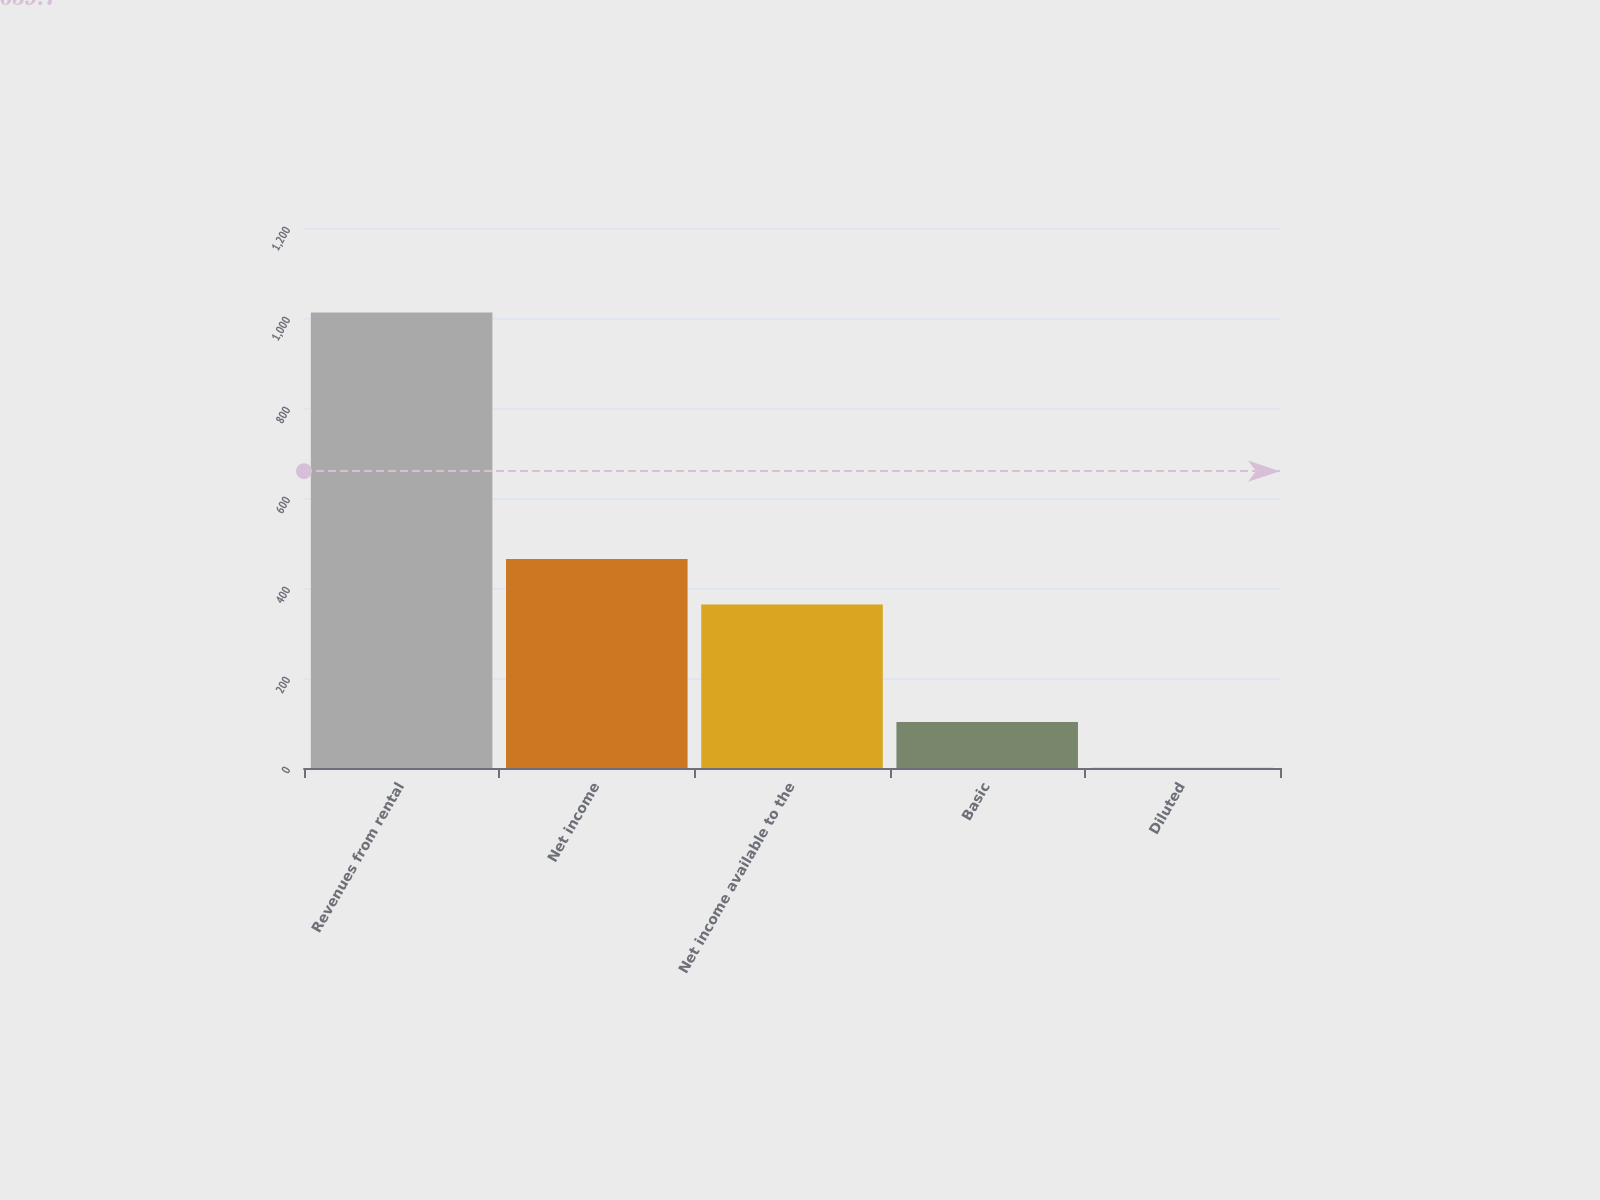<chart> <loc_0><loc_0><loc_500><loc_500><bar_chart><fcel>Revenues from rental<fcel>Net income<fcel>Net income available to the<fcel>Basic<fcel>Diluted<nl><fcel>1012.5<fcel>464.56<fcel>363.4<fcel>102.04<fcel>0.88<nl></chart> 